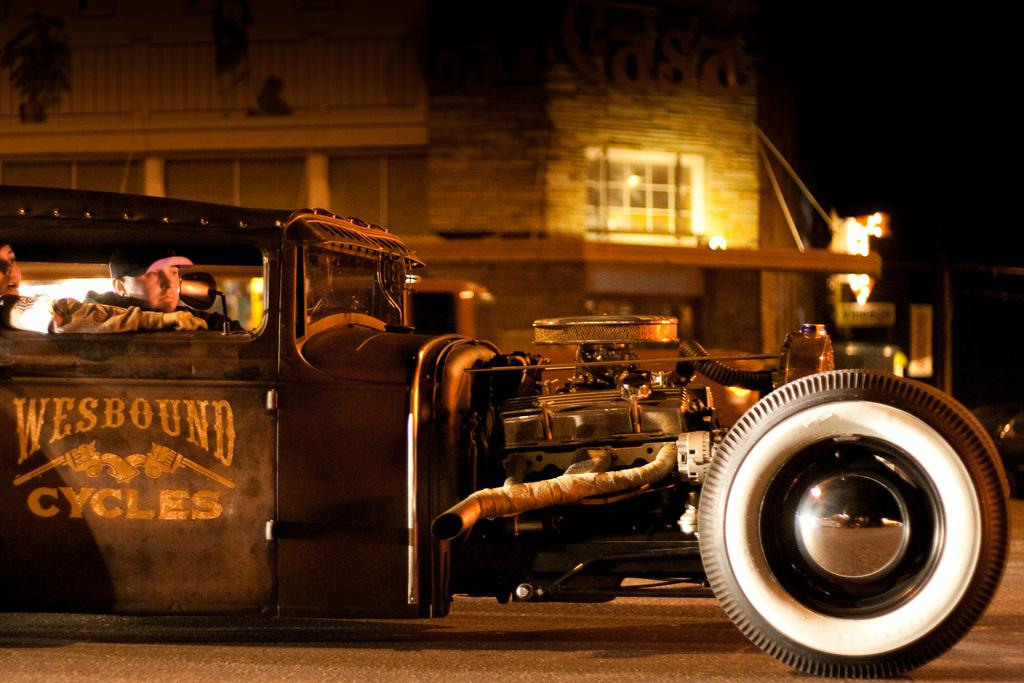What is the main subject in the foreground of the picture? There is a car in the foreground of the picture. Where is the car located? The car is on the road. Can you describe the background of the image? The background of the image is blurred. What can be seen in the background of the image? There is a building in the background of the image. What time does the clock on the car show in the image? There is no clock visible on the car in the image. What type of government is depicted in the image? There is no reference to any government or political entity in the image. 